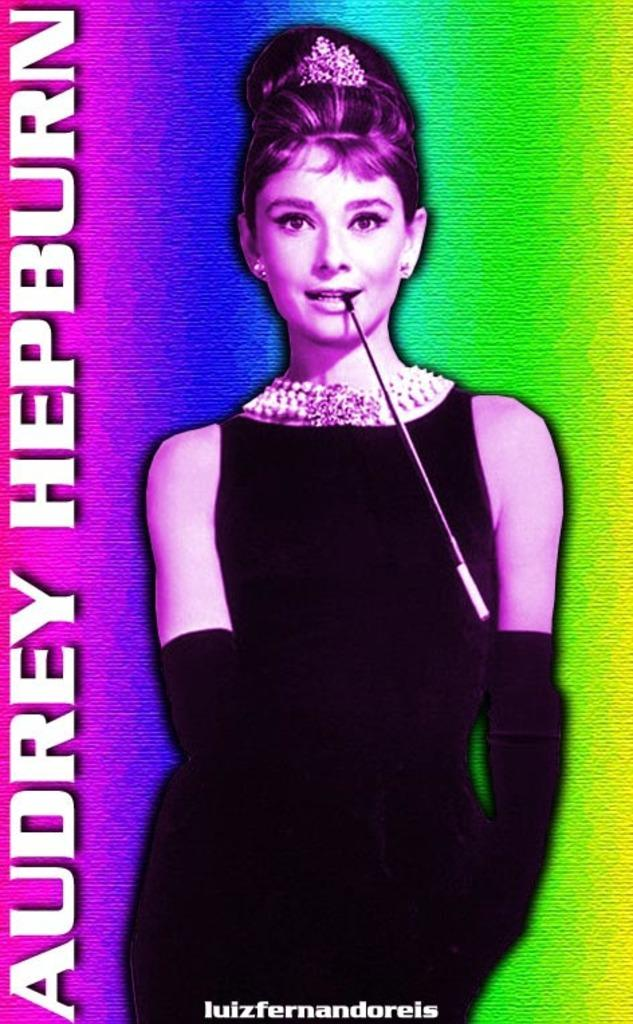Who is the main subject of the image? The main subject of the image is Audrey Hepburn. What is Audrey Hepburn wearing in the image? Audrey Hepburn is wearing a black dress, black gloves, and a white neck piece in the image. What type of event is Audrey Hepburn attending in the image? There is no information about an event in the image, as it only features Audrey Hepburn and her attire. 